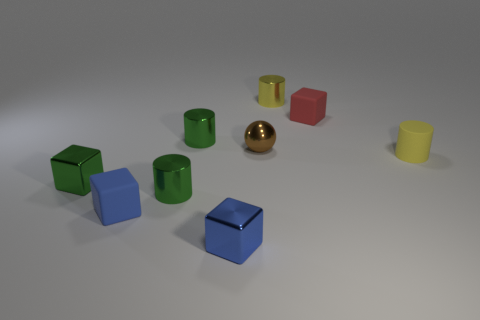Is the color of the tiny matte cylinder the same as the shiny object on the right side of the tiny brown sphere?
Your answer should be very brief. Yes. Is there a brown metal sphere that has the same size as the green shiny block?
Offer a very short reply. Yes. What material is the red thing that is behind the small green shiny cylinder in front of the tiny brown sphere made of?
Make the answer very short. Rubber. What number of matte blocks have the same color as the small ball?
Make the answer very short. 0. There is a blue object that is the same material as the small brown ball; what shape is it?
Give a very brief answer. Cube. Are there an equal number of green shiny cylinders that are on the right side of the yellow metallic cylinder and rubber cylinders behind the brown metal ball?
Offer a very short reply. Yes. The metallic object in front of the blue cube left of the metallic block that is on the right side of the green block is what color?
Offer a very short reply. Blue. What number of small blocks are both right of the small blue matte cube and in front of the green shiny cube?
Offer a very short reply. 1. There is a rubber thing to the left of the small brown thing; is its color the same as the small metallic block that is on the right side of the tiny green shiny cube?
Your answer should be very brief. Yes. What size is the yellow matte object that is the same shape as the small yellow metallic thing?
Provide a short and direct response. Small. 